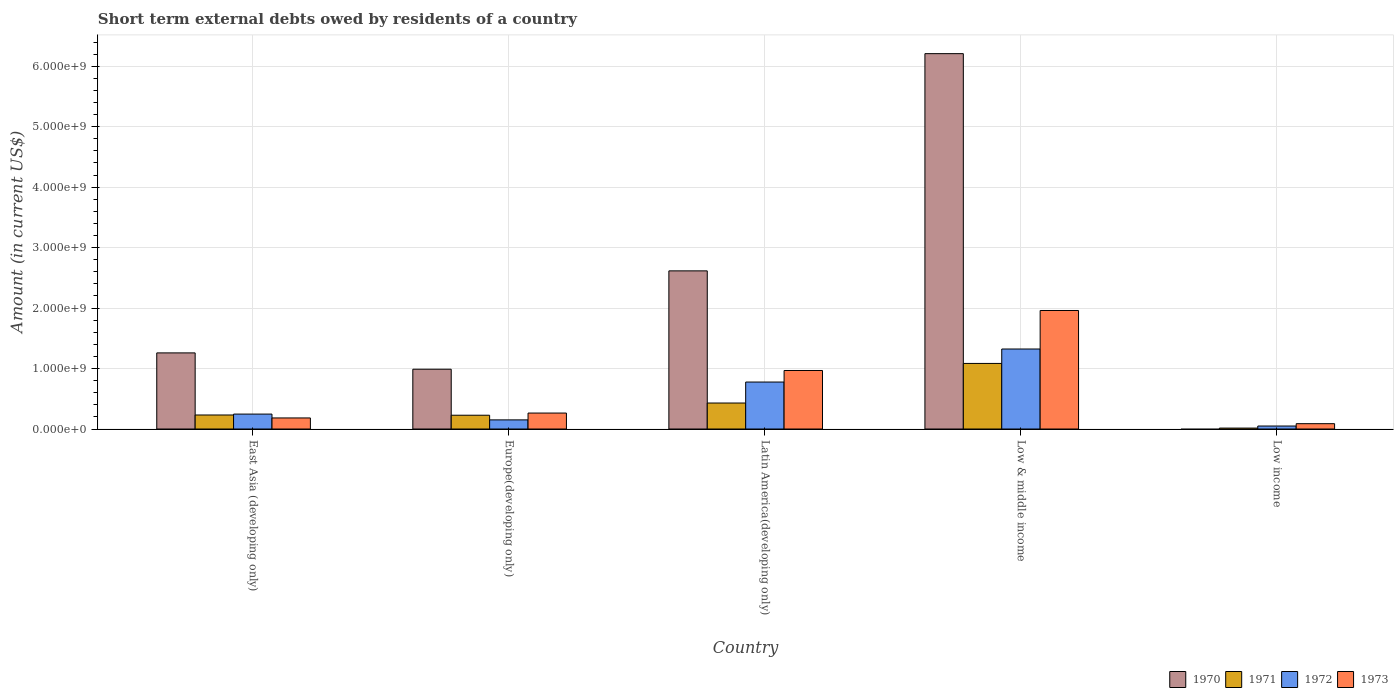How many groups of bars are there?
Your answer should be very brief. 5. Are the number of bars per tick equal to the number of legend labels?
Keep it short and to the point. No. How many bars are there on the 5th tick from the left?
Provide a succinct answer. 3. What is the label of the 1st group of bars from the left?
Give a very brief answer. East Asia (developing only). What is the amount of short-term external debts owed by residents in 1971 in Low income?
Offer a very short reply. 1.54e+07. Across all countries, what is the maximum amount of short-term external debts owed by residents in 1973?
Your answer should be very brief. 1.96e+09. Across all countries, what is the minimum amount of short-term external debts owed by residents in 1972?
Ensure brevity in your answer.  4.94e+07. In which country was the amount of short-term external debts owed by residents in 1973 maximum?
Make the answer very short. Low & middle income. What is the total amount of short-term external debts owed by residents in 1972 in the graph?
Make the answer very short. 2.55e+09. What is the difference between the amount of short-term external debts owed by residents in 1972 in East Asia (developing only) and that in Low & middle income?
Your answer should be very brief. -1.08e+09. What is the difference between the amount of short-term external debts owed by residents in 1970 in Low & middle income and the amount of short-term external debts owed by residents in 1971 in East Asia (developing only)?
Give a very brief answer. 5.98e+09. What is the average amount of short-term external debts owed by residents in 1970 per country?
Give a very brief answer. 2.21e+09. What is the difference between the amount of short-term external debts owed by residents of/in 1972 and amount of short-term external debts owed by residents of/in 1970 in East Asia (developing only)?
Your answer should be very brief. -1.01e+09. What is the ratio of the amount of short-term external debts owed by residents in 1971 in Latin America(developing only) to that in Low income?
Give a very brief answer. 28.01. Is the amount of short-term external debts owed by residents in 1972 in Europe(developing only) less than that in Low income?
Provide a succinct answer. No. What is the difference between the highest and the second highest amount of short-term external debts owed by residents in 1971?
Your answer should be compact. 8.53e+08. What is the difference between the highest and the lowest amount of short-term external debts owed by residents in 1973?
Provide a succinct answer. 1.87e+09. In how many countries, is the amount of short-term external debts owed by residents in 1972 greater than the average amount of short-term external debts owed by residents in 1972 taken over all countries?
Your answer should be compact. 2. How many countries are there in the graph?
Your response must be concise. 5. Where does the legend appear in the graph?
Offer a terse response. Bottom right. How many legend labels are there?
Provide a short and direct response. 4. How are the legend labels stacked?
Provide a short and direct response. Horizontal. What is the title of the graph?
Provide a succinct answer. Short term external debts owed by residents of a country. Does "1965" appear as one of the legend labels in the graph?
Keep it short and to the point. No. What is the label or title of the Y-axis?
Offer a very short reply. Amount (in current US$). What is the Amount (in current US$) of 1970 in East Asia (developing only)?
Offer a terse response. 1.26e+09. What is the Amount (in current US$) in 1971 in East Asia (developing only)?
Give a very brief answer. 2.32e+08. What is the Amount (in current US$) of 1972 in East Asia (developing only)?
Provide a short and direct response. 2.47e+08. What is the Amount (in current US$) in 1973 in East Asia (developing only)?
Your answer should be very brief. 1.83e+08. What is the Amount (in current US$) of 1970 in Europe(developing only)?
Your response must be concise. 9.89e+08. What is the Amount (in current US$) of 1971 in Europe(developing only)?
Your response must be concise. 2.28e+08. What is the Amount (in current US$) in 1972 in Europe(developing only)?
Your answer should be very brief. 1.51e+08. What is the Amount (in current US$) of 1973 in Europe(developing only)?
Offer a terse response. 2.64e+08. What is the Amount (in current US$) of 1970 in Latin America(developing only)?
Ensure brevity in your answer.  2.62e+09. What is the Amount (in current US$) of 1971 in Latin America(developing only)?
Provide a succinct answer. 4.30e+08. What is the Amount (in current US$) of 1972 in Latin America(developing only)?
Keep it short and to the point. 7.77e+08. What is the Amount (in current US$) in 1973 in Latin America(developing only)?
Your answer should be very brief. 9.68e+08. What is the Amount (in current US$) of 1970 in Low & middle income?
Provide a short and direct response. 6.21e+09. What is the Amount (in current US$) of 1971 in Low & middle income?
Make the answer very short. 1.08e+09. What is the Amount (in current US$) in 1972 in Low & middle income?
Keep it short and to the point. 1.32e+09. What is the Amount (in current US$) in 1973 in Low & middle income?
Offer a very short reply. 1.96e+09. What is the Amount (in current US$) of 1970 in Low income?
Ensure brevity in your answer.  0. What is the Amount (in current US$) of 1971 in Low income?
Provide a succinct answer. 1.54e+07. What is the Amount (in current US$) of 1972 in Low income?
Keep it short and to the point. 4.94e+07. What is the Amount (in current US$) of 1973 in Low income?
Keep it short and to the point. 8.84e+07. Across all countries, what is the maximum Amount (in current US$) in 1970?
Your response must be concise. 6.21e+09. Across all countries, what is the maximum Amount (in current US$) in 1971?
Your response must be concise. 1.08e+09. Across all countries, what is the maximum Amount (in current US$) of 1972?
Keep it short and to the point. 1.32e+09. Across all countries, what is the maximum Amount (in current US$) in 1973?
Give a very brief answer. 1.96e+09. Across all countries, what is the minimum Amount (in current US$) in 1971?
Offer a very short reply. 1.54e+07. Across all countries, what is the minimum Amount (in current US$) of 1972?
Your answer should be very brief. 4.94e+07. Across all countries, what is the minimum Amount (in current US$) of 1973?
Provide a short and direct response. 8.84e+07. What is the total Amount (in current US$) of 1970 in the graph?
Give a very brief answer. 1.11e+1. What is the total Amount (in current US$) of 1971 in the graph?
Ensure brevity in your answer.  1.99e+09. What is the total Amount (in current US$) in 1972 in the graph?
Keep it short and to the point. 2.55e+09. What is the total Amount (in current US$) of 1973 in the graph?
Your answer should be compact. 3.46e+09. What is the difference between the Amount (in current US$) of 1970 in East Asia (developing only) and that in Europe(developing only)?
Provide a short and direct response. 2.70e+08. What is the difference between the Amount (in current US$) of 1972 in East Asia (developing only) and that in Europe(developing only)?
Provide a short and direct response. 9.60e+07. What is the difference between the Amount (in current US$) of 1973 in East Asia (developing only) and that in Europe(developing only)?
Keep it short and to the point. -8.10e+07. What is the difference between the Amount (in current US$) of 1970 in East Asia (developing only) and that in Latin America(developing only)?
Provide a short and direct response. -1.36e+09. What is the difference between the Amount (in current US$) of 1971 in East Asia (developing only) and that in Latin America(developing only)?
Keep it short and to the point. -1.98e+08. What is the difference between the Amount (in current US$) of 1972 in East Asia (developing only) and that in Latin America(developing only)?
Ensure brevity in your answer.  -5.30e+08. What is the difference between the Amount (in current US$) of 1973 in East Asia (developing only) and that in Latin America(developing only)?
Give a very brief answer. -7.85e+08. What is the difference between the Amount (in current US$) in 1970 in East Asia (developing only) and that in Low & middle income?
Keep it short and to the point. -4.95e+09. What is the difference between the Amount (in current US$) of 1971 in East Asia (developing only) and that in Low & middle income?
Your response must be concise. -8.53e+08. What is the difference between the Amount (in current US$) in 1972 in East Asia (developing only) and that in Low & middle income?
Offer a terse response. -1.08e+09. What is the difference between the Amount (in current US$) in 1973 in East Asia (developing only) and that in Low & middle income?
Ensure brevity in your answer.  -1.78e+09. What is the difference between the Amount (in current US$) in 1971 in East Asia (developing only) and that in Low income?
Keep it short and to the point. 2.17e+08. What is the difference between the Amount (in current US$) of 1972 in East Asia (developing only) and that in Low income?
Your response must be concise. 1.98e+08. What is the difference between the Amount (in current US$) of 1973 in East Asia (developing only) and that in Low income?
Keep it short and to the point. 9.46e+07. What is the difference between the Amount (in current US$) of 1970 in Europe(developing only) and that in Latin America(developing only)?
Provide a short and direct response. -1.63e+09. What is the difference between the Amount (in current US$) in 1971 in Europe(developing only) and that in Latin America(developing only)?
Offer a terse response. -2.02e+08. What is the difference between the Amount (in current US$) in 1972 in Europe(developing only) and that in Latin America(developing only)?
Ensure brevity in your answer.  -6.26e+08. What is the difference between the Amount (in current US$) in 1973 in Europe(developing only) and that in Latin America(developing only)?
Provide a succinct answer. -7.04e+08. What is the difference between the Amount (in current US$) of 1970 in Europe(developing only) and that in Low & middle income?
Provide a short and direct response. -5.22e+09. What is the difference between the Amount (in current US$) in 1971 in Europe(developing only) and that in Low & middle income?
Provide a succinct answer. -8.57e+08. What is the difference between the Amount (in current US$) in 1972 in Europe(developing only) and that in Low & middle income?
Your response must be concise. -1.17e+09. What is the difference between the Amount (in current US$) in 1973 in Europe(developing only) and that in Low & middle income?
Your answer should be very brief. -1.70e+09. What is the difference between the Amount (in current US$) of 1971 in Europe(developing only) and that in Low income?
Ensure brevity in your answer.  2.13e+08. What is the difference between the Amount (in current US$) of 1972 in Europe(developing only) and that in Low income?
Make the answer very short. 1.02e+08. What is the difference between the Amount (in current US$) in 1973 in Europe(developing only) and that in Low income?
Give a very brief answer. 1.76e+08. What is the difference between the Amount (in current US$) in 1970 in Latin America(developing only) and that in Low & middle income?
Your response must be concise. -3.59e+09. What is the difference between the Amount (in current US$) in 1971 in Latin America(developing only) and that in Low & middle income?
Offer a very short reply. -6.55e+08. What is the difference between the Amount (in current US$) of 1972 in Latin America(developing only) and that in Low & middle income?
Provide a short and direct response. -5.46e+08. What is the difference between the Amount (in current US$) of 1973 in Latin America(developing only) and that in Low & middle income?
Offer a very short reply. -9.92e+08. What is the difference between the Amount (in current US$) in 1971 in Latin America(developing only) and that in Low income?
Keep it short and to the point. 4.15e+08. What is the difference between the Amount (in current US$) of 1972 in Latin America(developing only) and that in Low income?
Make the answer very short. 7.28e+08. What is the difference between the Amount (in current US$) of 1973 in Latin America(developing only) and that in Low income?
Offer a terse response. 8.80e+08. What is the difference between the Amount (in current US$) in 1971 in Low & middle income and that in Low income?
Keep it short and to the point. 1.07e+09. What is the difference between the Amount (in current US$) in 1972 in Low & middle income and that in Low income?
Provide a succinct answer. 1.27e+09. What is the difference between the Amount (in current US$) of 1973 in Low & middle income and that in Low income?
Provide a succinct answer. 1.87e+09. What is the difference between the Amount (in current US$) in 1970 in East Asia (developing only) and the Amount (in current US$) in 1971 in Europe(developing only)?
Your answer should be very brief. 1.03e+09. What is the difference between the Amount (in current US$) of 1970 in East Asia (developing only) and the Amount (in current US$) of 1972 in Europe(developing only)?
Give a very brief answer. 1.11e+09. What is the difference between the Amount (in current US$) of 1970 in East Asia (developing only) and the Amount (in current US$) of 1973 in Europe(developing only)?
Give a very brief answer. 9.95e+08. What is the difference between the Amount (in current US$) of 1971 in East Asia (developing only) and the Amount (in current US$) of 1972 in Europe(developing only)?
Your answer should be very brief. 8.10e+07. What is the difference between the Amount (in current US$) of 1971 in East Asia (developing only) and the Amount (in current US$) of 1973 in Europe(developing only)?
Provide a short and direct response. -3.20e+07. What is the difference between the Amount (in current US$) in 1972 in East Asia (developing only) and the Amount (in current US$) in 1973 in Europe(developing only)?
Offer a very short reply. -1.70e+07. What is the difference between the Amount (in current US$) of 1970 in East Asia (developing only) and the Amount (in current US$) of 1971 in Latin America(developing only)?
Give a very brief answer. 8.29e+08. What is the difference between the Amount (in current US$) in 1970 in East Asia (developing only) and the Amount (in current US$) in 1972 in Latin America(developing only)?
Ensure brevity in your answer.  4.82e+08. What is the difference between the Amount (in current US$) in 1970 in East Asia (developing only) and the Amount (in current US$) in 1973 in Latin America(developing only)?
Make the answer very short. 2.91e+08. What is the difference between the Amount (in current US$) in 1971 in East Asia (developing only) and the Amount (in current US$) in 1972 in Latin America(developing only)?
Keep it short and to the point. -5.45e+08. What is the difference between the Amount (in current US$) of 1971 in East Asia (developing only) and the Amount (in current US$) of 1973 in Latin America(developing only)?
Provide a short and direct response. -7.36e+08. What is the difference between the Amount (in current US$) of 1972 in East Asia (developing only) and the Amount (in current US$) of 1973 in Latin America(developing only)?
Your answer should be compact. -7.21e+08. What is the difference between the Amount (in current US$) in 1970 in East Asia (developing only) and the Amount (in current US$) in 1971 in Low & middle income?
Your answer should be compact. 1.74e+08. What is the difference between the Amount (in current US$) of 1970 in East Asia (developing only) and the Amount (in current US$) of 1972 in Low & middle income?
Offer a terse response. -6.43e+07. What is the difference between the Amount (in current US$) in 1970 in East Asia (developing only) and the Amount (in current US$) in 1973 in Low & middle income?
Provide a succinct answer. -7.01e+08. What is the difference between the Amount (in current US$) in 1971 in East Asia (developing only) and the Amount (in current US$) in 1972 in Low & middle income?
Your answer should be very brief. -1.09e+09. What is the difference between the Amount (in current US$) of 1971 in East Asia (developing only) and the Amount (in current US$) of 1973 in Low & middle income?
Make the answer very short. -1.73e+09. What is the difference between the Amount (in current US$) in 1972 in East Asia (developing only) and the Amount (in current US$) in 1973 in Low & middle income?
Offer a terse response. -1.71e+09. What is the difference between the Amount (in current US$) of 1970 in East Asia (developing only) and the Amount (in current US$) of 1971 in Low income?
Keep it short and to the point. 1.24e+09. What is the difference between the Amount (in current US$) in 1970 in East Asia (developing only) and the Amount (in current US$) in 1972 in Low income?
Ensure brevity in your answer.  1.21e+09. What is the difference between the Amount (in current US$) of 1970 in East Asia (developing only) and the Amount (in current US$) of 1973 in Low income?
Your answer should be compact. 1.17e+09. What is the difference between the Amount (in current US$) in 1971 in East Asia (developing only) and the Amount (in current US$) in 1972 in Low income?
Give a very brief answer. 1.83e+08. What is the difference between the Amount (in current US$) of 1971 in East Asia (developing only) and the Amount (in current US$) of 1973 in Low income?
Ensure brevity in your answer.  1.44e+08. What is the difference between the Amount (in current US$) of 1972 in East Asia (developing only) and the Amount (in current US$) of 1973 in Low income?
Your response must be concise. 1.59e+08. What is the difference between the Amount (in current US$) of 1970 in Europe(developing only) and the Amount (in current US$) of 1971 in Latin America(developing only)?
Give a very brief answer. 5.59e+08. What is the difference between the Amount (in current US$) in 1970 in Europe(developing only) and the Amount (in current US$) in 1972 in Latin America(developing only)?
Your response must be concise. 2.12e+08. What is the difference between the Amount (in current US$) in 1970 in Europe(developing only) and the Amount (in current US$) in 1973 in Latin America(developing only)?
Your answer should be very brief. 2.10e+07. What is the difference between the Amount (in current US$) in 1971 in Europe(developing only) and the Amount (in current US$) in 1972 in Latin America(developing only)?
Ensure brevity in your answer.  -5.49e+08. What is the difference between the Amount (in current US$) of 1971 in Europe(developing only) and the Amount (in current US$) of 1973 in Latin America(developing only)?
Provide a short and direct response. -7.40e+08. What is the difference between the Amount (in current US$) in 1972 in Europe(developing only) and the Amount (in current US$) in 1973 in Latin America(developing only)?
Your answer should be very brief. -8.17e+08. What is the difference between the Amount (in current US$) in 1970 in Europe(developing only) and the Amount (in current US$) in 1971 in Low & middle income?
Offer a terse response. -9.58e+07. What is the difference between the Amount (in current US$) of 1970 in Europe(developing only) and the Amount (in current US$) of 1972 in Low & middle income?
Keep it short and to the point. -3.34e+08. What is the difference between the Amount (in current US$) of 1970 in Europe(developing only) and the Amount (in current US$) of 1973 in Low & middle income?
Give a very brief answer. -9.71e+08. What is the difference between the Amount (in current US$) of 1971 in Europe(developing only) and the Amount (in current US$) of 1972 in Low & middle income?
Your response must be concise. -1.10e+09. What is the difference between the Amount (in current US$) of 1971 in Europe(developing only) and the Amount (in current US$) of 1973 in Low & middle income?
Provide a succinct answer. -1.73e+09. What is the difference between the Amount (in current US$) in 1972 in Europe(developing only) and the Amount (in current US$) in 1973 in Low & middle income?
Give a very brief answer. -1.81e+09. What is the difference between the Amount (in current US$) in 1970 in Europe(developing only) and the Amount (in current US$) in 1971 in Low income?
Provide a short and direct response. 9.74e+08. What is the difference between the Amount (in current US$) of 1970 in Europe(developing only) and the Amount (in current US$) of 1972 in Low income?
Provide a succinct answer. 9.40e+08. What is the difference between the Amount (in current US$) in 1970 in Europe(developing only) and the Amount (in current US$) in 1973 in Low income?
Your response must be concise. 9.01e+08. What is the difference between the Amount (in current US$) of 1971 in Europe(developing only) and the Amount (in current US$) of 1972 in Low income?
Provide a succinct answer. 1.79e+08. What is the difference between the Amount (in current US$) in 1971 in Europe(developing only) and the Amount (in current US$) in 1973 in Low income?
Make the answer very short. 1.40e+08. What is the difference between the Amount (in current US$) of 1972 in Europe(developing only) and the Amount (in current US$) of 1973 in Low income?
Provide a short and direct response. 6.26e+07. What is the difference between the Amount (in current US$) of 1970 in Latin America(developing only) and the Amount (in current US$) of 1971 in Low & middle income?
Give a very brief answer. 1.53e+09. What is the difference between the Amount (in current US$) in 1970 in Latin America(developing only) and the Amount (in current US$) in 1972 in Low & middle income?
Offer a very short reply. 1.29e+09. What is the difference between the Amount (in current US$) of 1970 in Latin America(developing only) and the Amount (in current US$) of 1973 in Low & middle income?
Provide a short and direct response. 6.55e+08. What is the difference between the Amount (in current US$) in 1971 in Latin America(developing only) and the Amount (in current US$) in 1972 in Low & middle income?
Offer a very short reply. -8.93e+08. What is the difference between the Amount (in current US$) of 1971 in Latin America(developing only) and the Amount (in current US$) of 1973 in Low & middle income?
Provide a short and direct response. -1.53e+09. What is the difference between the Amount (in current US$) in 1972 in Latin America(developing only) and the Amount (in current US$) in 1973 in Low & middle income?
Make the answer very short. -1.18e+09. What is the difference between the Amount (in current US$) of 1970 in Latin America(developing only) and the Amount (in current US$) of 1971 in Low income?
Your response must be concise. 2.60e+09. What is the difference between the Amount (in current US$) in 1970 in Latin America(developing only) and the Amount (in current US$) in 1972 in Low income?
Provide a succinct answer. 2.57e+09. What is the difference between the Amount (in current US$) in 1970 in Latin America(developing only) and the Amount (in current US$) in 1973 in Low income?
Ensure brevity in your answer.  2.53e+09. What is the difference between the Amount (in current US$) in 1971 in Latin America(developing only) and the Amount (in current US$) in 1972 in Low income?
Your answer should be compact. 3.81e+08. What is the difference between the Amount (in current US$) in 1971 in Latin America(developing only) and the Amount (in current US$) in 1973 in Low income?
Provide a short and direct response. 3.42e+08. What is the difference between the Amount (in current US$) of 1972 in Latin America(developing only) and the Amount (in current US$) of 1973 in Low income?
Offer a terse response. 6.89e+08. What is the difference between the Amount (in current US$) of 1970 in Low & middle income and the Amount (in current US$) of 1971 in Low income?
Your response must be concise. 6.19e+09. What is the difference between the Amount (in current US$) in 1970 in Low & middle income and the Amount (in current US$) in 1972 in Low income?
Provide a succinct answer. 6.16e+09. What is the difference between the Amount (in current US$) of 1970 in Low & middle income and the Amount (in current US$) of 1973 in Low income?
Provide a succinct answer. 6.12e+09. What is the difference between the Amount (in current US$) of 1971 in Low & middle income and the Amount (in current US$) of 1972 in Low income?
Your response must be concise. 1.04e+09. What is the difference between the Amount (in current US$) of 1971 in Low & middle income and the Amount (in current US$) of 1973 in Low income?
Offer a very short reply. 9.96e+08. What is the difference between the Amount (in current US$) of 1972 in Low & middle income and the Amount (in current US$) of 1973 in Low income?
Keep it short and to the point. 1.23e+09. What is the average Amount (in current US$) in 1970 per country?
Give a very brief answer. 2.21e+09. What is the average Amount (in current US$) in 1971 per country?
Offer a terse response. 3.98e+08. What is the average Amount (in current US$) of 1972 per country?
Provide a short and direct response. 5.10e+08. What is the average Amount (in current US$) in 1973 per country?
Your answer should be very brief. 6.93e+08. What is the difference between the Amount (in current US$) of 1970 and Amount (in current US$) of 1971 in East Asia (developing only)?
Provide a short and direct response. 1.03e+09. What is the difference between the Amount (in current US$) in 1970 and Amount (in current US$) in 1972 in East Asia (developing only)?
Your answer should be very brief. 1.01e+09. What is the difference between the Amount (in current US$) in 1970 and Amount (in current US$) in 1973 in East Asia (developing only)?
Provide a short and direct response. 1.08e+09. What is the difference between the Amount (in current US$) in 1971 and Amount (in current US$) in 1972 in East Asia (developing only)?
Keep it short and to the point. -1.50e+07. What is the difference between the Amount (in current US$) in 1971 and Amount (in current US$) in 1973 in East Asia (developing only)?
Offer a terse response. 4.90e+07. What is the difference between the Amount (in current US$) of 1972 and Amount (in current US$) of 1973 in East Asia (developing only)?
Provide a short and direct response. 6.40e+07. What is the difference between the Amount (in current US$) in 1970 and Amount (in current US$) in 1971 in Europe(developing only)?
Your answer should be compact. 7.61e+08. What is the difference between the Amount (in current US$) in 1970 and Amount (in current US$) in 1972 in Europe(developing only)?
Provide a short and direct response. 8.38e+08. What is the difference between the Amount (in current US$) in 1970 and Amount (in current US$) in 1973 in Europe(developing only)?
Provide a short and direct response. 7.25e+08. What is the difference between the Amount (in current US$) in 1971 and Amount (in current US$) in 1972 in Europe(developing only)?
Provide a short and direct response. 7.70e+07. What is the difference between the Amount (in current US$) of 1971 and Amount (in current US$) of 1973 in Europe(developing only)?
Your answer should be very brief. -3.60e+07. What is the difference between the Amount (in current US$) in 1972 and Amount (in current US$) in 1973 in Europe(developing only)?
Provide a succinct answer. -1.13e+08. What is the difference between the Amount (in current US$) in 1970 and Amount (in current US$) in 1971 in Latin America(developing only)?
Your response must be concise. 2.19e+09. What is the difference between the Amount (in current US$) in 1970 and Amount (in current US$) in 1972 in Latin America(developing only)?
Keep it short and to the point. 1.84e+09. What is the difference between the Amount (in current US$) in 1970 and Amount (in current US$) in 1973 in Latin America(developing only)?
Give a very brief answer. 1.65e+09. What is the difference between the Amount (in current US$) of 1971 and Amount (in current US$) of 1972 in Latin America(developing only)?
Offer a very short reply. -3.47e+08. What is the difference between the Amount (in current US$) in 1971 and Amount (in current US$) in 1973 in Latin America(developing only)?
Provide a succinct answer. -5.38e+08. What is the difference between the Amount (in current US$) of 1972 and Amount (in current US$) of 1973 in Latin America(developing only)?
Provide a succinct answer. -1.91e+08. What is the difference between the Amount (in current US$) of 1970 and Amount (in current US$) of 1971 in Low & middle income?
Your answer should be very brief. 5.12e+09. What is the difference between the Amount (in current US$) in 1970 and Amount (in current US$) in 1972 in Low & middle income?
Make the answer very short. 4.89e+09. What is the difference between the Amount (in current US$) in 1970 and Amount (in current US$) in 1973 in Low & middle income?
Ensure brevity in your answer.  4.25e+09. What is the difference between the Amount (in current US$) in 1971 and Amount (in current US$) in 1972 in Low & middle income?
Provide a succinct answer. -2.39e+08. What is the difference between the Amount (in current US$) in 1971 and Amount (in current US$) in 1973 in Low & middle income?
Your answer should be very brief. -8.76e+08. What is the difference between the Amount (in current US$) in 1972 and Amount (in current US$) in 1973 in Low & middle income?
Give a very brief answer. -6.37e+08. What is the difference between the Amount (in current US$) in 1971 and Amount (in current US$) in 1972 in Low income?
Keep it short and to the point. -3.40e+07. What is the difference between the Amount (in current US$) in 1971 and Amount (in current US$) in 1973 in Low income?
Offer a very short reply. -7.30e+07. What is the difference between the Amount (in current US$) in 1972 and Amount (in current US$) in 1973 in Low income?
Offer a terse response. -3.90e+07. What is the ratio of the Amount (in current US$) of 1970 in East Asia (developing only) to that in Europe(developing only)?
Keep it short and to the point. 1.27. What is the ratio of the Amount (in current US$) of 1971 in East Asia (developing only) to that in Europe(developing only)?
Your response must be concise. 1.02. What is the ratio of the Amount (in current US$) of 1972 in East Asia (developing only) to that in Europe(developing only)?
Your answer should be very brief. 1.64. What is the ratio of the Amount (in current US$) in 1973 in East Asia (developing only) to that in Europe(developing only)?
Ensure brevity in your answer.  0.69. What is the ratio of the Amount (in current US$) of 1970 in East Asia (developing only) to that in Latin America(developing only)?
Provide a succinct answer. 0.48. What is the ratio of the Amount (in current US$) in 1971 in East Asia (developing only) to that in Latin America(developing only)?
Keep it short and to the point. 0.54. What is the ratio of the Amount (in current US$) in 1972 in East Asia (developing only) to that in Latin America(developing only)?
Offer a very short reply. 0.32. What is the ratio of the Amount (in current US$) of 1973 in East Asia (developing only) to that in Latin America(developing only)?
Provide a short and direct response. 0.19. What is the ratio of the Amount (in current US$) of 1970 in East Asia (developing only) to that in Low & middle income?
Provide a short and direct response. 0.2. What is the ratio of the Amount (in current US$) of 1971 in East Asia (developing only) to that in Low & middle income?
Your answer should be compact. 0.21. What is the ratio of the Amount (in current US$) in 1972 in East Asia (developing only) to that in Low & middle income?
Your response must be concise. 0.19. What is the ratio of the Amount (in current US$) of 1973 in East Asia (developing only) to that in Low & middle income?
Give a very brief answer. 0.09. What is the ratio of the Amount (in current US$) of 1971 in East Asia (developing only) to that in Low income?
Your response must be concise. 15.11. What is the ratio of the Amount (in current US$) in 1972 in East Asia (developing only) to that in Low income?
Your answer should be compact. 5. What is the ratio of the Amount (in current US$) in 1973 in East Asia (developing only) to that in Low income?
Make the answer very short. 2.07. What is the ratio of the Amount (in current US$) in 1970 in Europe(developing only) to that in Latin America(developing only)?
Ensure brevity in your answer.  0.38. What is the ratio of the Amount (in current US$) of 1971 in Europe(developing only) to that in Latin America(developing only)?
Make the answer very short. 0.53. What is the ratio of the Amount (in current US$) of 1972 in Europe(developing only) to that in Latin America(developing only)?
Provide a succinct answer. 0.19. What is the ratio of the Amount (in current US$) of 1973 in Europe(developing only) to that in Latin America(developing only)?
Make the answer very short. 0.27. What is the ratio of the Amount (in current US$) in 1970 in Europe(developing only) to that in Low & middle income?
Make the answer very short. 0.16. What is the ratio of the Amount (in current US$) of 1971 in Europe(developing only) to that in Low & middle income?
Provide a short and direct response. 0.21. What is the ratio of the Amount (in current US$) of 1972 in Europe(developing only) to that in Low & middle income?
Your answer should be compact. 0.11. What is the ratio of the Amount (in current US$) of 1973 in Europe(developing only) to that in Low & middle income?
Give a very brief answer. 0.13. What is the ratio of the Amount (in current US$) of 1971 in Europe(developing only) to that in Low income?
Make the answer very short. 14.85. What is the ratio of the Amount (in current US$) of 1972 in Europe(developing only) to that in Low income?
Ensure brevity in your answer.  3.06. What is the ratio of the Amount (in current US$) in 1973 in Europe(developing only) to that in Low income?
Offer a terse response. 2.99. What is the ratio of the Amount (in current US$) of 1970 in Latin America(developing only) to that in Low & middle income?
Keep it short and to the point. 0.42. What is the ratio of the Amount (in current US$) in 1971 in Latin America(developing only) to that in Low & middle income?
Your response must be concise. 0.4. What is the ratio of the Amount (in current US$) in 1972 in Latin America(developing only) to that in Low & middle income?
Make the answer very short. 0.59. What is the ratio of the Amount (in current US$) in 1973 in Latin America(developing only) to that in Low & middle income?
Give a very brief answer. 0.49. What is the ratio of the Amount (in current US$) of 1971 in Latin America(developing only) to that in Low income?
Make the answer very short. 28.01. What is the ratio of the Amount (in current US$) of 1972 in Latin America(developing only) to that in Low income?
Offer a very short reply. 15.74. What is the ratio of the Amount (in current US$) in 1973 in Latin America(developing only) to that in Low income?
Ensure brevity in your answer.  10.96. What is the ratio of the Amount (in current US$) of 1971 in Low & middle income to that in Low income?
Offer a very short reply. 70.65. What is the ratio of the Amount (in current US$) of 1972 in Low & middle income to that in Low income?
Provide a short and direct response. 26.81. What is the ratio of the Amount (in current US$) in 1973 in Low & middle income to that in Low income?
Offer a very short reply. 22.19. What is the difference between the highest and the second highest Amount (in current US$) of 1970?
Give a very brief answer. 3.59e+09. What is the difference between the highest and the second highest Amount (in current US$) of 1971?
Give a very brief answer. 6.55e+08. What is the difference between the highest and the second highest Amount (in current US$) in 1972?
Provide a short and direct response. 5.46e+08. What is the difference between the highest and the second highest Amount (in current US$) in 1973?
Keep it short and to the point. 9.92e+08. What is the difference between the highest and the lowest Amount (in current US$) in 1970?
Your answer should be very brief. 6.21e+09. What is the difference between the highest and the lowest Amount (in current US$) of 1971?
Provide a short and direct response. 1.07e+09. What is the difference between the highest and the lowest Amount (in current US$) of 1972?
Your answer should be compact. 1.27e+09. What is the difference between the highest and the lowest Amount (in current US$) of 1973?
Keep it short and to the point. 1.87e+09. 